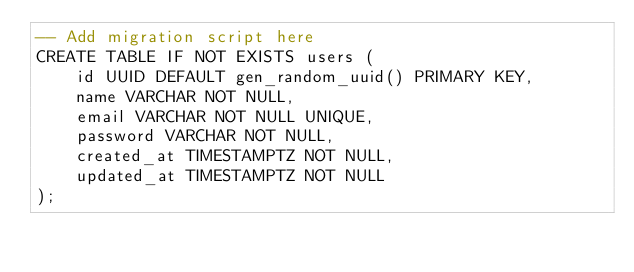<code> <loc_0><loc_0><loc_500><loc_500><_SQL_>-- Add migration script here
CREATE TABLE IF NOT EXISTS users (
    id UUID DEFAULT gen_random_uuid() PRIMARY KEY,
    name VARCHAR NOT NULL,
    email VARCHAR NOT NULL UNIQUE,
    password VARCHAR NOT NULL,
    created_at TIMESTAMPTZ NOT NULL,
    updated_at TIMESTAMPTZ NOT NULL
);
</code> 